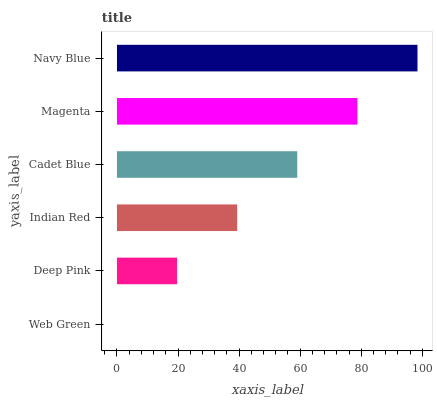Is Web Green the minimum?
Answer yes or no. Yes. Is Navy Blue the maximum?
Answer yes or no. Yes. Is Deep Pink the minimum?
Answer yes or no. No. Is Deep Pink the maximum?
Answer yes or no. No. Is Deep Pink greater than Web Green?
Answer yes or no. Yes. Is Web Green less than Deep Pink?
Answer yes or no. Yes. Is Web Green greater than Deep Pink?
Answer yes or no. No. Is Deep Pink less than Web Green?
Answer yes or no. No. Is Cadet Blue the high median?
Answer yes or no. Yes. Is Indian Red the low median?
Answer yes or no. Yes. Is Indian Red the high median?
Answer yes or no. No. Is Cadet Blue the low median?
Answer yes or no. No. 